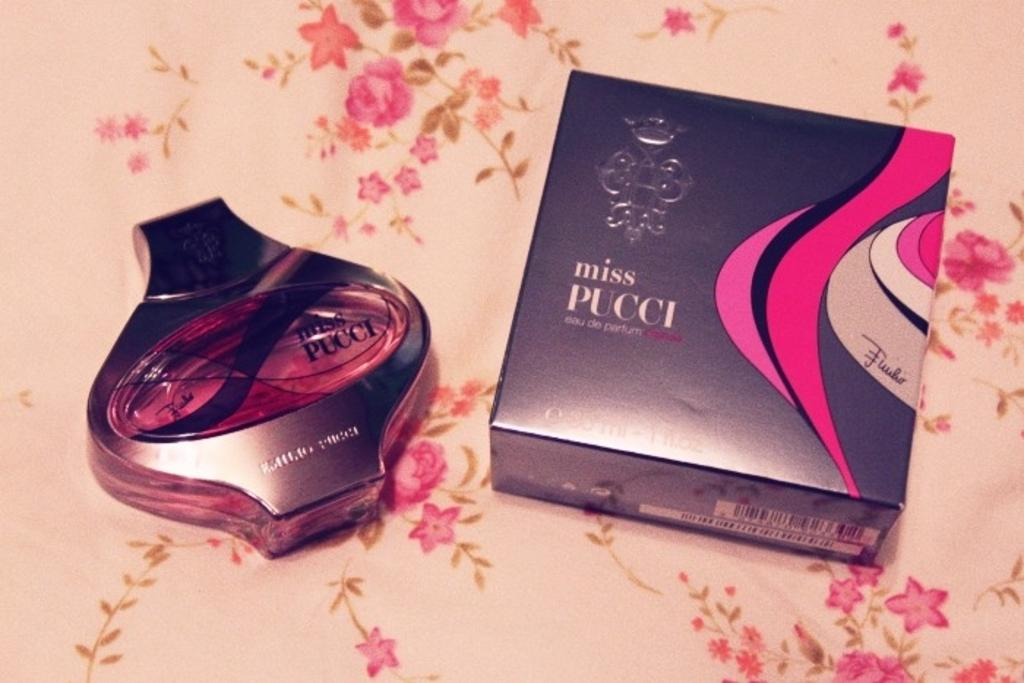Provide a one-sentence caption for the provided image. Box and perfume bottle of Miss Pucci on a cloth. 